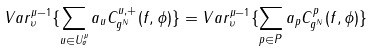<formula> <loc_0><loc_0><loc_500><loc_500>V a r ^ { \mu - 1 } _ { \upsilon } \{ \sum _ { u \in U ^ { \mu } _ { \sigma } } a _ { u } C ^ { u , + } _ { g ^ { N } } ( f , \phi ) \} = V a r ^ { \mu - 1 } _ { \upsilon } \{ \sum _ { p \in P } a _ { p } C ^ { p } _ { g ^ { N } } ( f , \phi ) \}</formula> 